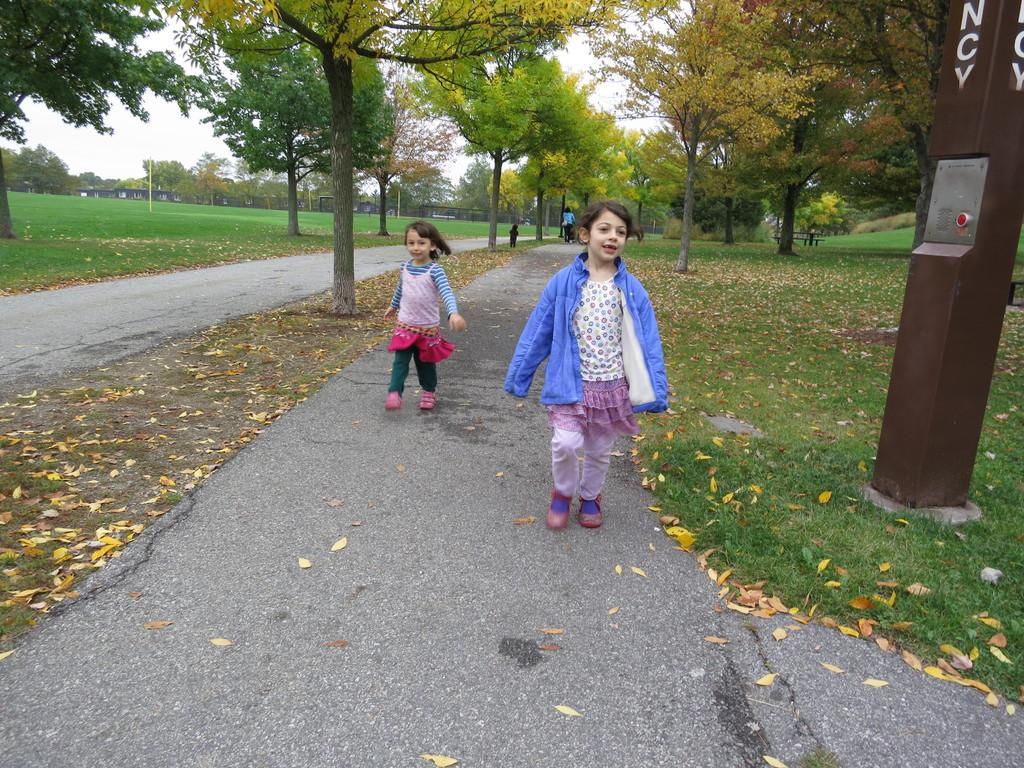What are the two main subjects in the image? There are two girls walking on the road in the image. What can be seen on the ground in the image? Dried leaves and grass are visible in the image. Can you describe the object in the image? There is an object in the image, but its specific nature is not clear from the provided facts. What else can be seen in the background of the image? There are people, trees, a wall, and the sky visible in the background of the image. What type of farmer is visible in the image? There is no farmer present in the image. How does the swing move in the image? There is no swing present in the image. 